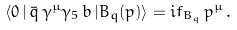<formula> <loc_0><loc_0><loc_500><loc_500>\langle 0 \, | \, \bar { q } \, \gamma ^ { \mu } \gamma _ { 5 } \, b \, | B _ { q } ( p ) \rangle = i f _ { B _ { q } } \, p ^ { \mu } \, .</formula> 